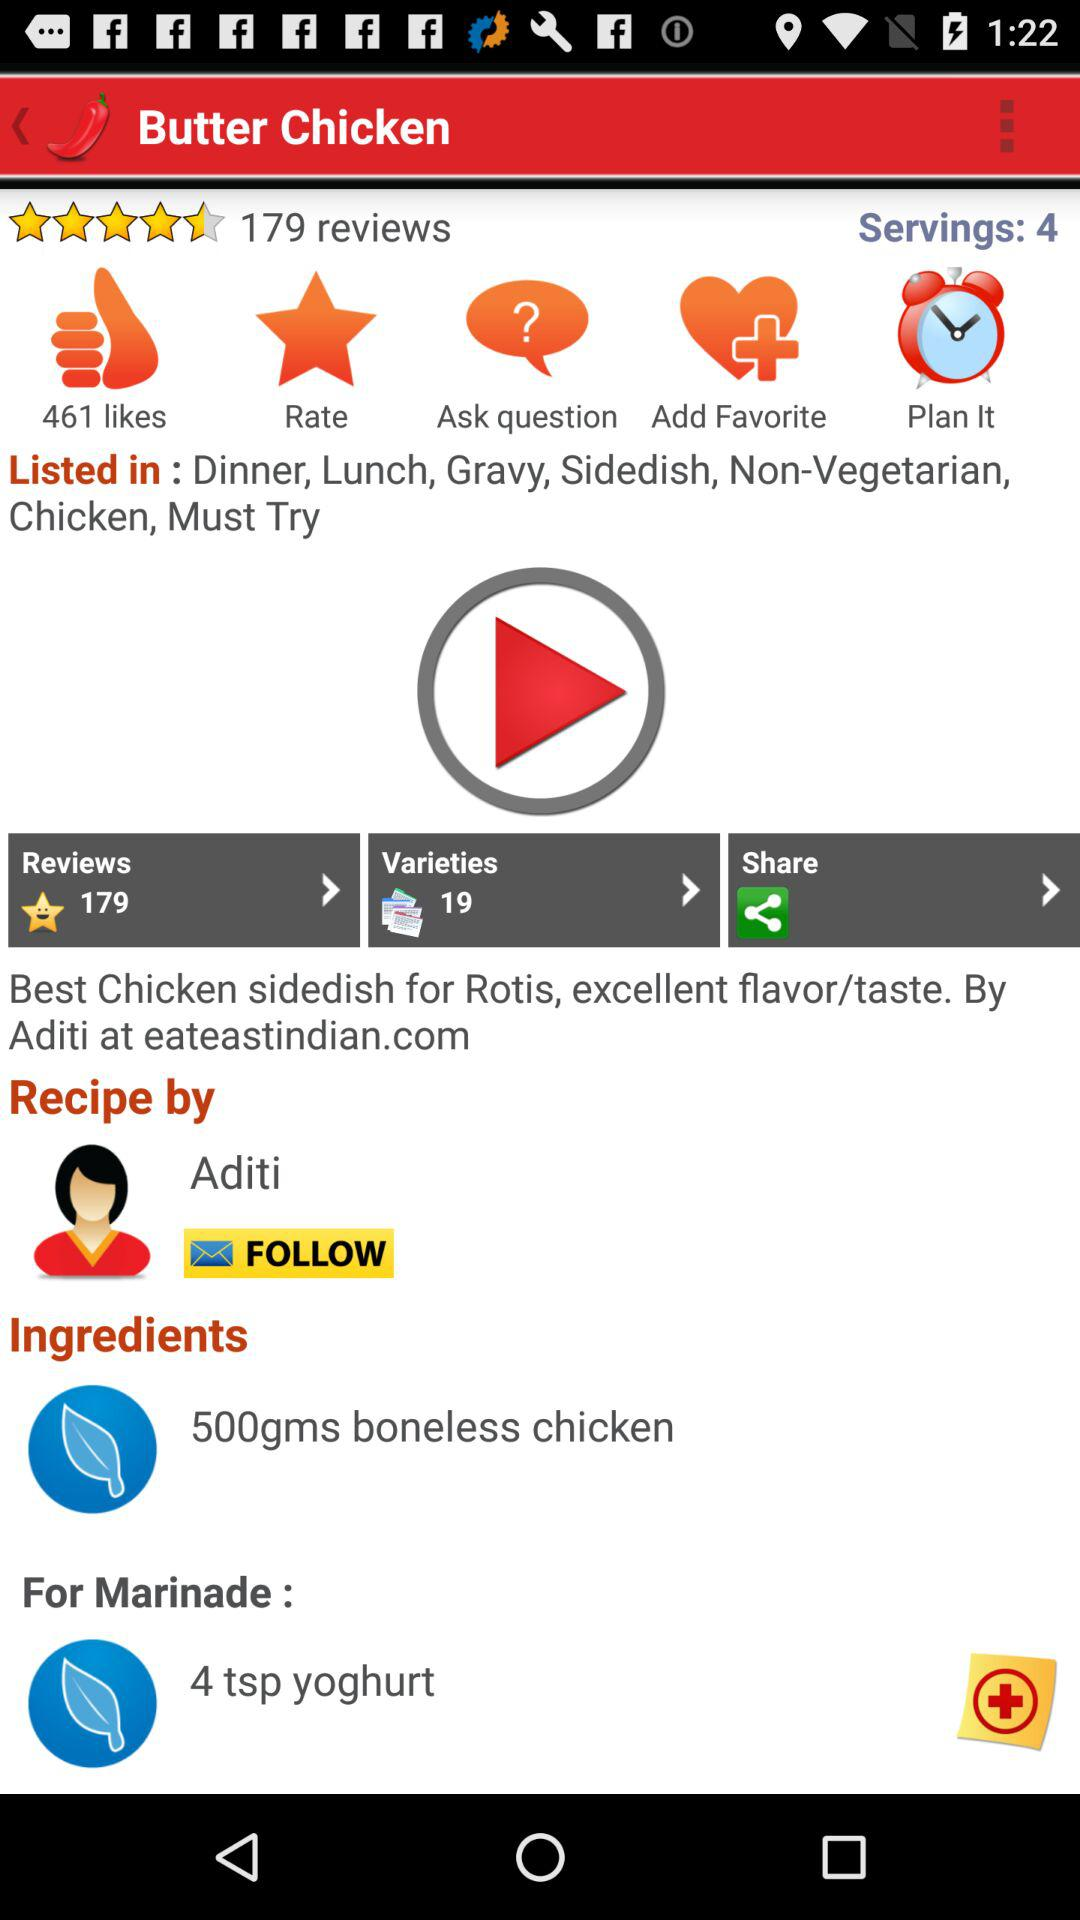Who gave the recipe? The recipe is given by Aditi. 